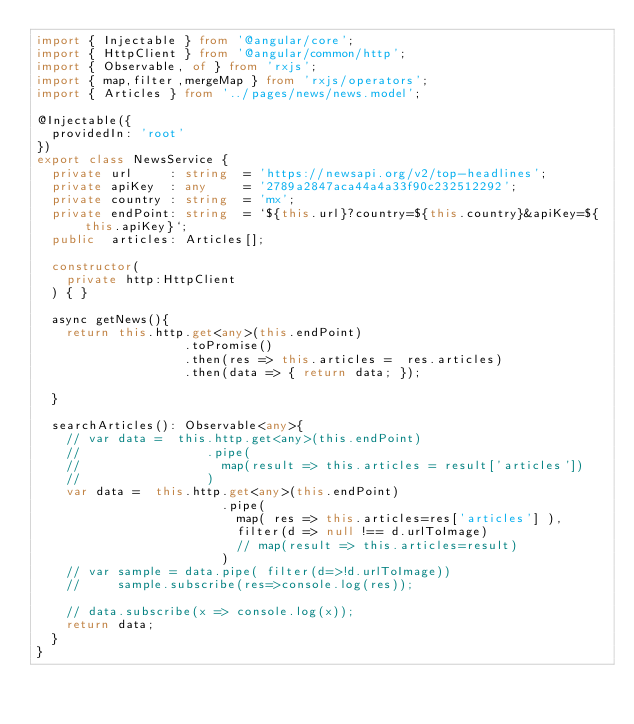Convert code to text. <code><loc_0><loc_0><loc_500><loc_500><_TypeScript_>import { Injectable } from '@angular/core';
import { HttpClient } from '@angular/common/http';
import { Observable, of } from 'rxjs';
import { map,filter,mergeMap } from 'rxjs/operators';
import { Articles } from '../pages/news/news.model';

@Injectable({
  providedIn: 'root'
})
export class NewsService {
  private url     : string  = 'https://newsapi.org/v2/top-headlines';
  private apiKey  : any     = '2789a2847aca44a4a33f90c232512292';
  private country : string  = 'mx';
  private endPoint: string  = `${this.url}?country=${this.country}&apiKey=${this.apiKey}`;
  public  articles: Articles[];

  constructor(
    private http:HttpClient
  ) { }

  async getNews(){
    return this.http.get<any>(this.endPoint)
                    .toPromise()
                    .then(res => this.articles =  res.articles)
                    .then(data => { return data; });

  }

  searchArticles(): Observable<any>{
    // var data =  this.http.get<any>(this.endPoint)
    //                 .pipe(
    //                   map(result => this.articles = result['articles'])
    //                 )
    var data =  this.http.get<any>(this.endPoint)
                         .pipe(
                           map( res => this.articles=res['articles'] ),
                           filter(d => null !== d.urlToImage)  
                           // map(result => this.articles=result)
                         )
    // var sample = data.pipe( filter(d=>!d.urlToImage))
    //     sample.subscribe(res=>console.log(res));

    // data.subscribe(x => console.log(x));
    return data;
  }
}
</code> 